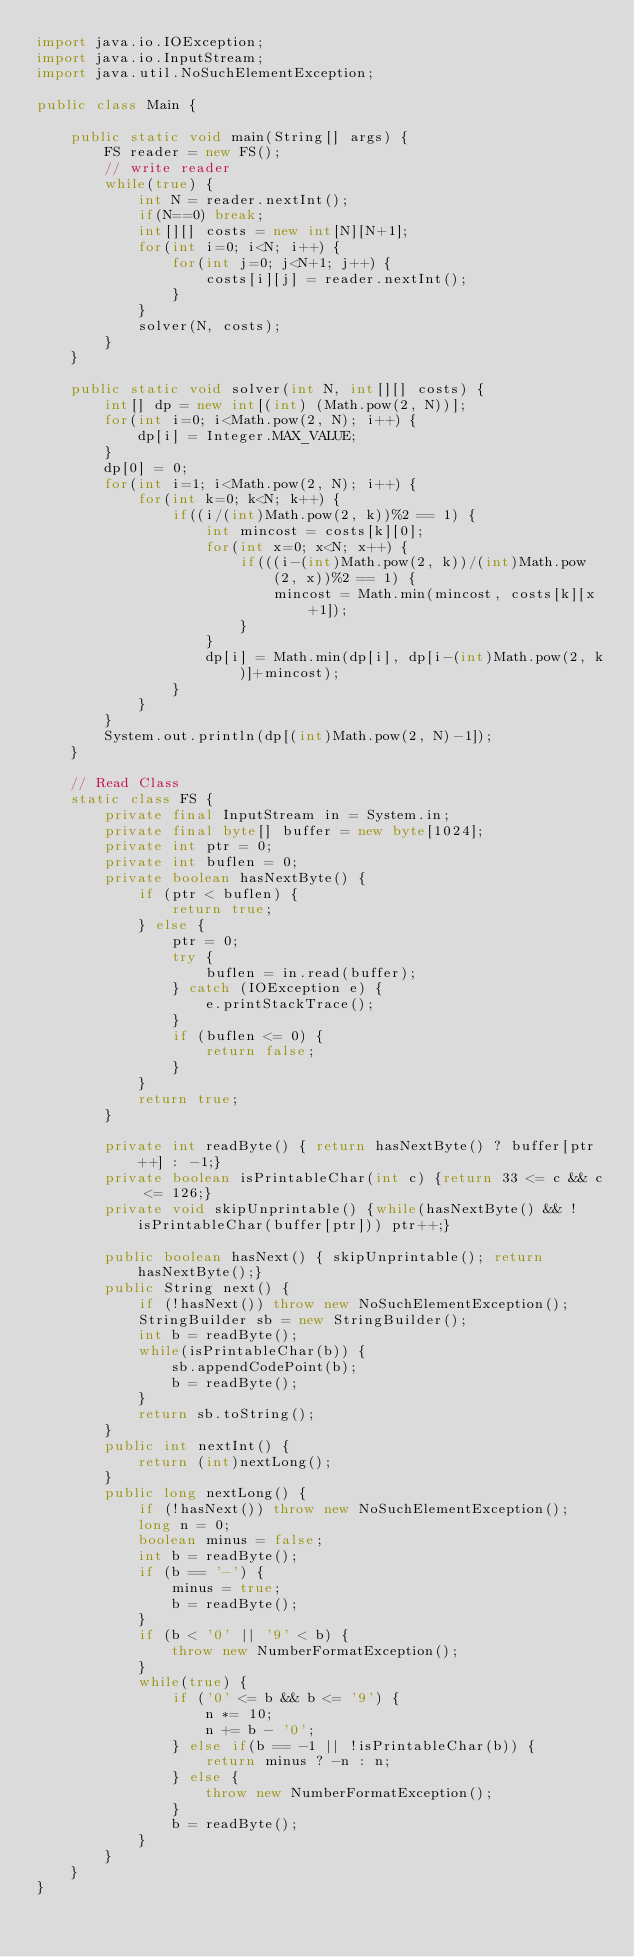<code> <loc_0><loc_0><loc_500><loc_500><_Java_>import java.io.IOException;
import java.io.InputStream;
import java.util.NoSuchElementException;

public class Main {

	public static void main(String[] args) {
		FS reader = new FS();
		// write reader
		while(true) {
			int N = reader.nextInt();
			if(N==0) break;
			int[][] costs = new int[N][N+1];
			for(int i=0; i<N; i++) {
				for(int j=0; j<N+1; j++) {
					costs[i][j] = reader.nextInt();
				}
			}
			solver(N, costs);
		}
	}

	public static void solver(int N, int[][] costs) {
		int[] dp = new int[(int) (Math.pow(2, N))];
		for(int i=0; i<Math.pow(2, N); i++) {
			dp[i] = Integer.MAX_VALUE;
		}
		dp[0] = 0;
		for(int i=1; i<Math.pow(2, N); i++) {
			for(int k=0; k<N; k++) {
				if((i/(int)Math.pow(2, k))%2 == 1) {
					int mincost = costs[k][0];
					for(int x=0; x<N; x++) {
						if(((i-(int)Math.pow(2, k))/(int)Math.pow(2, x))%2 == 1) {
							mincost = Math.min(mincost, costs[k][x+1]);
						}
					}
					dp[i] = Math.min(dp[i], dp[i-(int)Math.pow(2, k)]+mincost);
				}
			}
		}
		System.out.println(dp[(int)Math.pow(2, N)-1]);
	}

	// Read Class
	static class FS {
		private final InputStream in = System.in;
		private final byte[] buffer = new byte[1024];
		private int ptr = 0;
		private int buflen = 0;
		private boolean hasNextByte() {
			if (ptr < buflen) {
				return true;
			} else {
				ptr = 0;
				try {
					buflen = in.read(buffer);
				} catch (IOException e) {
					e.printStackTrace();
				}
				if (buflen <= 0) {
					return false;
				}
			}
			return true;
		}

		private int readByte() { return hasNextByte() ? buffer[ptr++] : -1;}
		private boolean isPrintableChar(int c) {return 33 <= c && c <= 126;}
		private void skipUnprintable() {while(hasNextByte() && !isPrintableChar(buffer[ptr])) ptr++;}

		public boolean hasNext() { skipUnprintable(); return hasNextByte();}
		public String next() {
			if (!hasNext()) throw new NoSuchElementException();
			StringBuilder sb = new StringBuilder();
			int b = readByte();
			while(isPrintableChar(b)) {
				sb.appendCodePoint(b);
				b = readByte();
			}
			return sb.toString();
		}
		public int nextInt() {
			return (int)nextLong();
		}
		public long nextLong() {
			if (!hasNext()) throw new NoSuchElementException();
			long n = 0;
			boolean minus = false;
			int b = readByte();
			if (b == '-') {
				minus = true;
				b = readByte();
			}
			if (b < '0' || '9' < b) {
				throw new NumberFormatException();
			}
			while(true) {
				if ('0' <= b && b <= '9') {
					n *= 10;
					n += b - '0';
				} else if(b == -1 || !isPrintableChar(b)) {
					return minus ? -n : n;
				} else {
					throw new NumberFormatException();
				}
				b = readByte();
			}
		}
	}
}</code> 